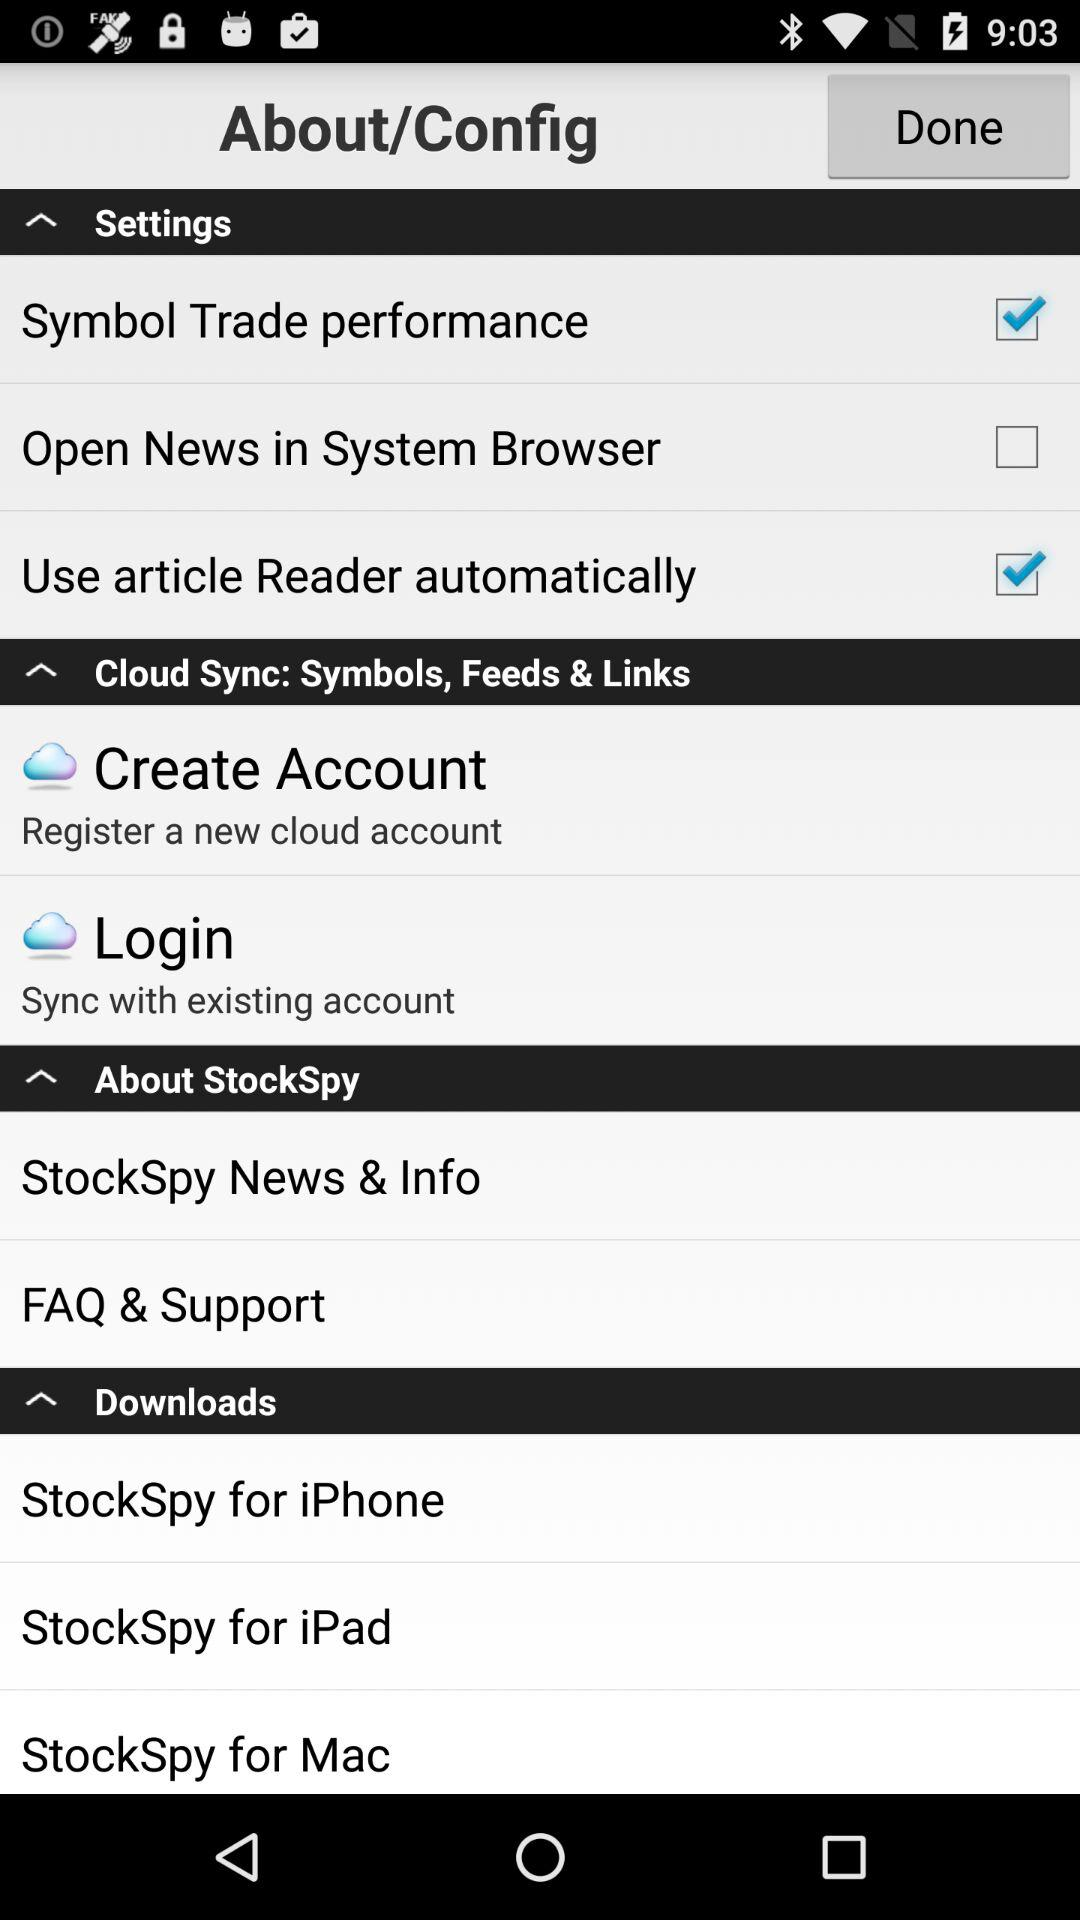What is the status of the "Symbol Trade performance"? The status is "on". 